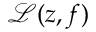<formula> <loc_0><loc_0><loc_500><loc_500>\mathcal { L } ( z , f )</formula> 